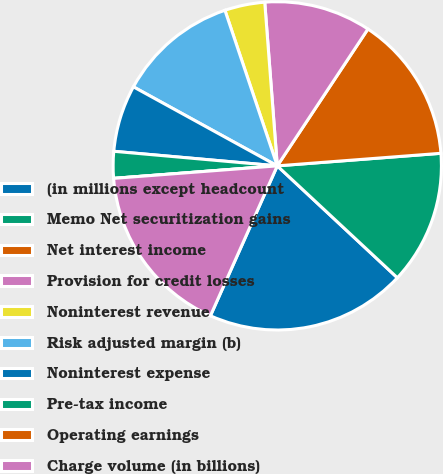Convert chart to OTSL. <chart><loc_0><loc_0><loc_500><loc_500><pie_chart><fcel>(in millions except headcount<fcel>Memo Net securitization gains<fcel>Net interest income<fcel>Provision for credit losses<fcel>Noninterest revenue<fcel>Risk adjusted margin (b)<fcel>Noninterest expense<fcel>Pre-tax income<fcel>Operating earnings<fcel>Charge volume (in billions)<nl><fcel>19.74%<fcel>13.16%<fcel>14.47%<fcel>10.53%<fcel>3.95%<fcel>11.84%<fcel>6.58%<fcel>2.63%<fcel>0.0%<fcel>17.11%<nl></chart> 